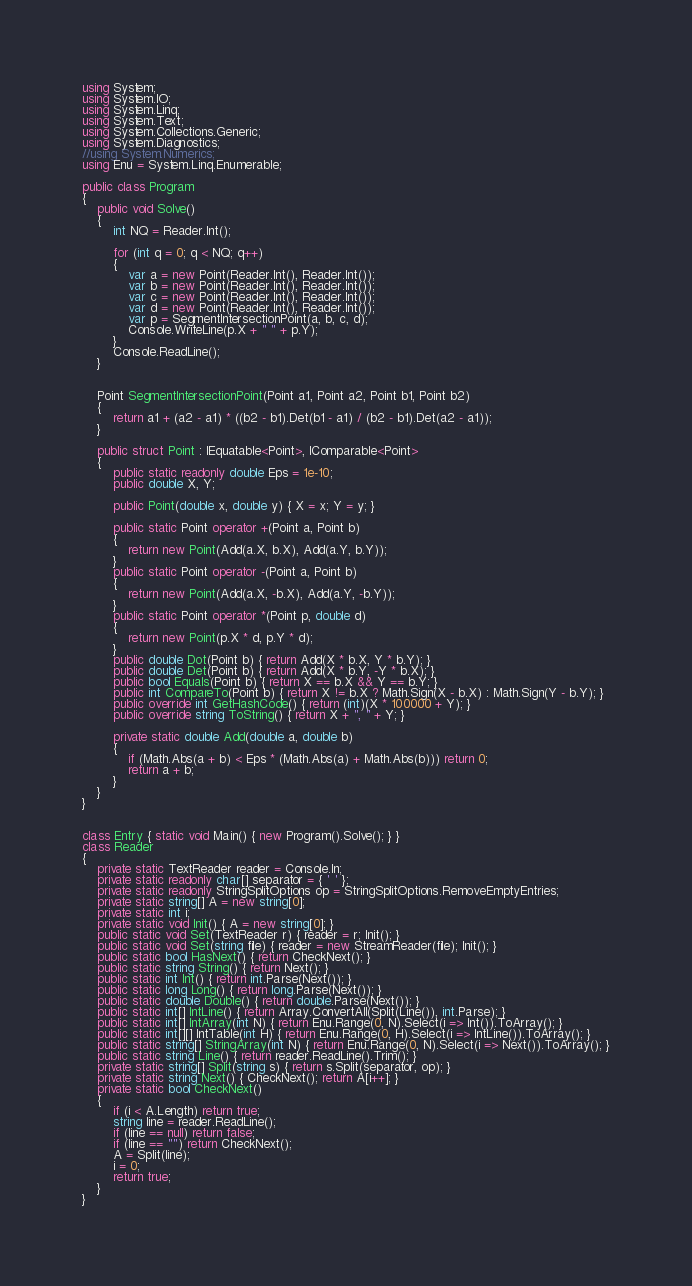<code> <loc_0><loc_0><loc_500><loc_500><_C#_>using System;
using System.IO;
using System.Linq;
using System.Text;
using System.Collections.Generic;
using System.Diagnostics;
//using System.Numerics;
using Enu = System.Linq.Enumerable;

public class Program
{
    public void Solve()
    {
        int NQ = Reader.Int();

        for (int q = 0; q < NQ; q++)
        {
            var a = new Point(Reader.Int(), Reader.Int());
            var b = new Point(Reader.Int(), Reader.Int());
            var c = new Point(Reader.Int(), Reader.Int());
            var d = new Point(Reader.Int(), Reader.Int());
            var p = SegmentIntersectionPoint(a, b, c, d);
            Console.WriteLine(p.X + " " + p.Y);
        }
        Console.ReadLine();
    }


    Point SegmentIntersectionPoint(Point a1, Point a2, Point b1, Point b2)
    {
        return a1 + (a2 - a1) * ((b2 - b1).Det(b1 - a1) / (b2 - b1).Det(a2 - a1));
    }

    public struct Point : IEquatable<Point>, IComparable<Point>
    {
        public static readonly double Eps = 1e-10;
        public double X, Y;

        public Point(double x, double y) { X = x; Y = y; }

        public static Point operator +(Point a, Point b)
        {
            return new Point(Add(a.X, b.X), Add(a.Y, b.Y));
        }
        public static Point operator -(Point a, Point b)
        {
            return new Point(Add(a.X, -b.X), Add(a.Y, -b.Y));
        }
        public static Point operator *(Point p, double d)
        {
            return new Point(p.X * d, p.Y * d);
        }
        public double Dot(Point b) { return Add(X * b.X, Y * b.Y); }
        public double Det(Point b) { return Add(X * b.Y, -Y * b.X); }
        public bool Equals(Point b) { return X == b.X && Y == b.Y; }
        public int CompareTo(Point b) { return X != b.X ? Math.Sign(X - b.X) : Math.Sign(Y - b.Y); }
        public override int GetHashCode() { return (int)(X * 100000 + Y); }
        public override string ToString() { return X + ", " + Y; }

        private static double Add(double a, double b)
        {
            if (Math.Abs(a + b) < Eps * (Math.Abs(a) + Math.Abs(b))) return 0;
            return a + b;
        }
    }
}


class Entry { static void Main() { new Program().Solve(); } }
class Reader
{
    private static TextReader reader = Console.In;
    private static readonly char[] separator = { ' ' };
    private static readonly StringSplitOptions op = StringSplitOptions.RemoveEmptyEntries;
    private static string[] A = new string[0];
    private static int i;
    private static void Init() { A = new string[0]; }
    public static void Set(TextReader r) { reader = r; Init(); }
    public static void Set(string file) { reader = new StreamReader(file); Init(); }
    public static bool HasNext() { return CheckNext(); }
    public static string String() { return Next(); }
    public static int Int() { return int.Parse(Next()); }
    public static long Long() { return long.Parse(Next()); }
    public static double Double() { return double.Parse(Next()); }
    public static int[] IntLine() { return Array.ConvertAll(Split(Line()), int.Parse); }
    public static int[] IntArray(int N) { return Enu.Range(0, N).Select(i => Int()).ToArray(); }
    public static int[][] IntTable(int H) { return Enu.Range(0, H).Select(i => IntLine()).ToArray(); }
    public static string[] StringArray(int N) { return Enu.Range(0, N).Select(i => Next()).ToArray(); }
    public static string Line() { return reader.ReadLine().Trim(); }
    private static string[] Split(string s) { return s.Split(separator, op); }
    private static string Next() { CheckNext(); return A[i++]; }
    private static bool CheckNext()
    {
        if (i < A.Length) return true;
        string line = reader.ReadLine();
        if (line == null) return false;
        if (line == "") return CheckNext();
        A = Split(line);
        i = 0;
        return true;
    }
}</code> 